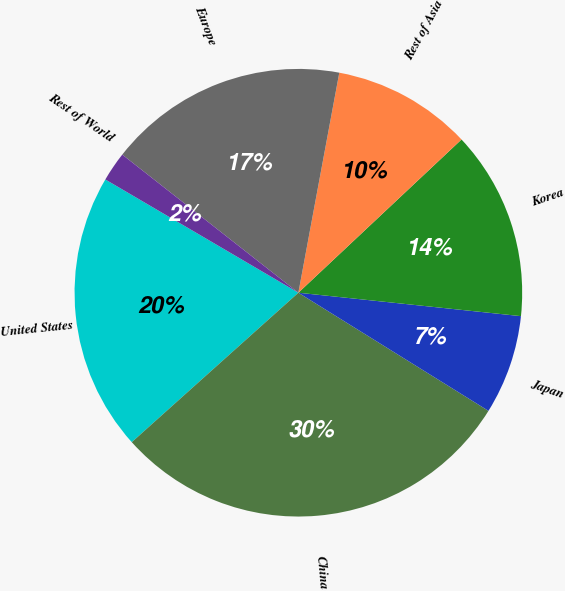<chart> <loc_0><loc_0><loc_500><loc_500><pie_chart><fcel>United States<fcel>China<fcel>Japan<fcel>Korea<fcel>Rest of Asia<fcel>Europe<fcel>Rest of World<nl><fcel>20.08%<fcel>29.51%<fcel>7.18%<fcel>13.67%<fcel>10.07%<fcel>17.34%<fcel>2.14%<nl></chart> 